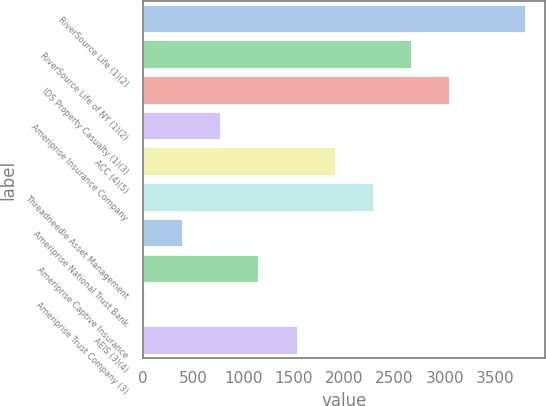<chart> <loc_0><loc_0><loc_500><loc_500><bar_chart><fcel>RiverSource Life (1)(2)<fcel>RiverSource Life of NY (1)(2)<fcel>IDS Property Casualty (1)(3)<fcel>Ameriprise Insurance Company<fcel>ACC (4)(5)<fcel>Threadneedle Asset Management<fcel>Ameriprise National Trust Bank<fcel>Ameriprise Captive Insurance<fcel>Ameriprise Trust Company (3)<fcel>AEIS (3)(4)<nl><fcel>3800<fcel>2668.1<fcel>3045.4<fcel>781.6<fcel>1913.5<fcel>2290.8<fcel>404.3<fcel>1158.9<fcel>27<fcel>1536.2<nl></chart> 